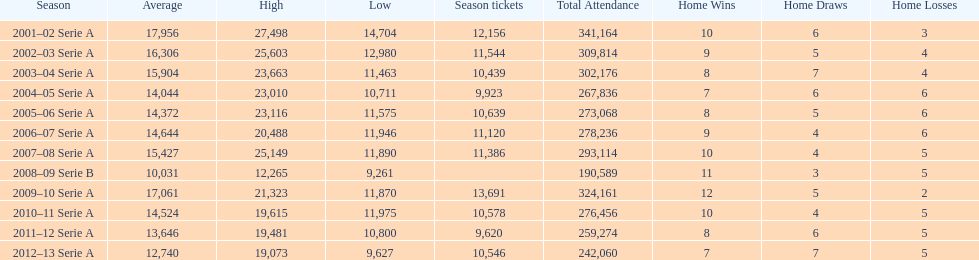What was the average in 2001 17,956. 